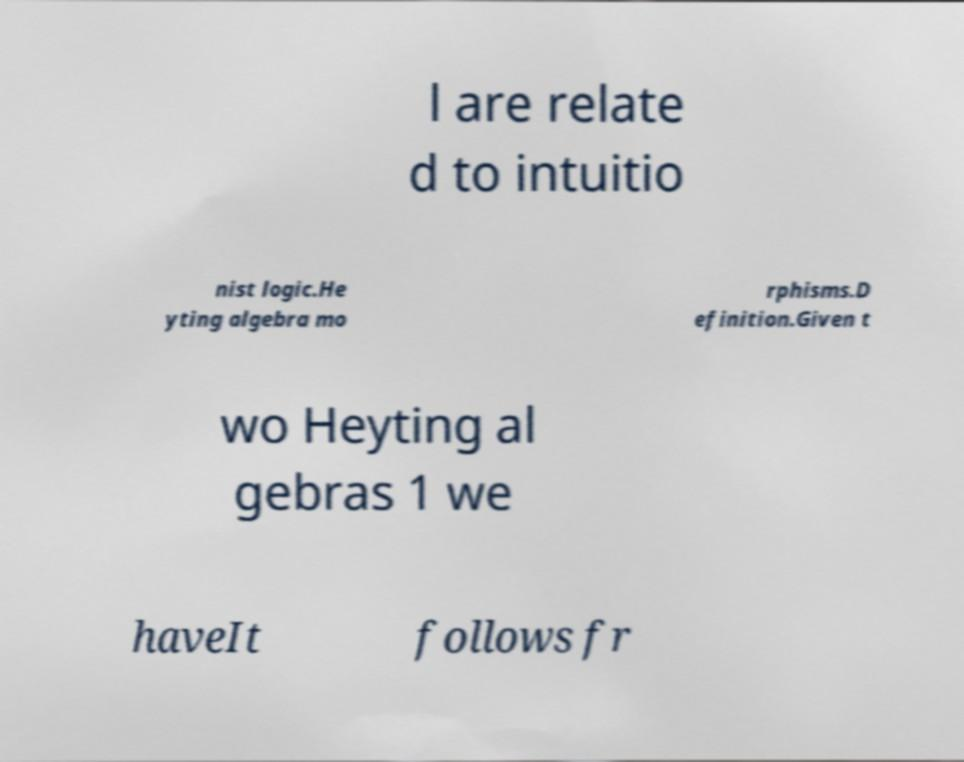Please identify and transcribe the text found in this image. l are relate d to intuitio nist logic.He yting algebra mo rphisms.D efinition.Given t wo Heyting al gebras 1 we haveIt follows fr 